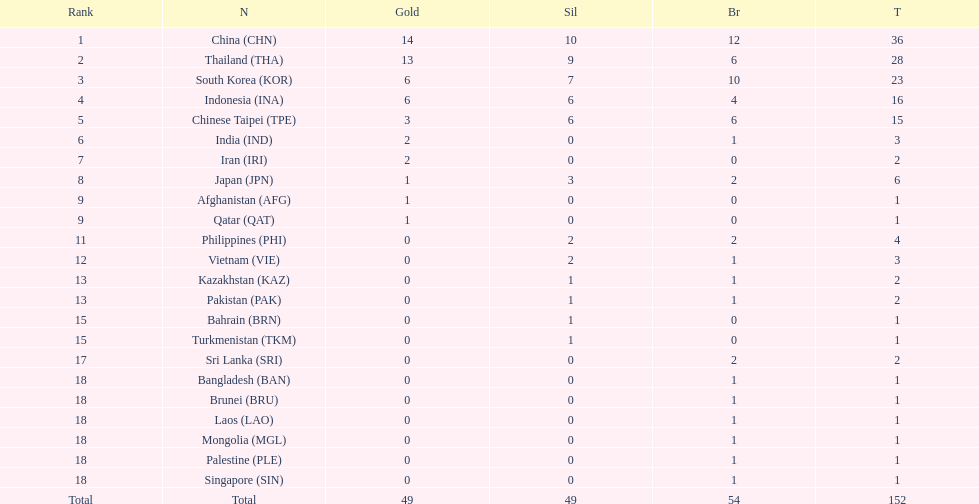What is the number of nations with zero silver medals won? 11. 